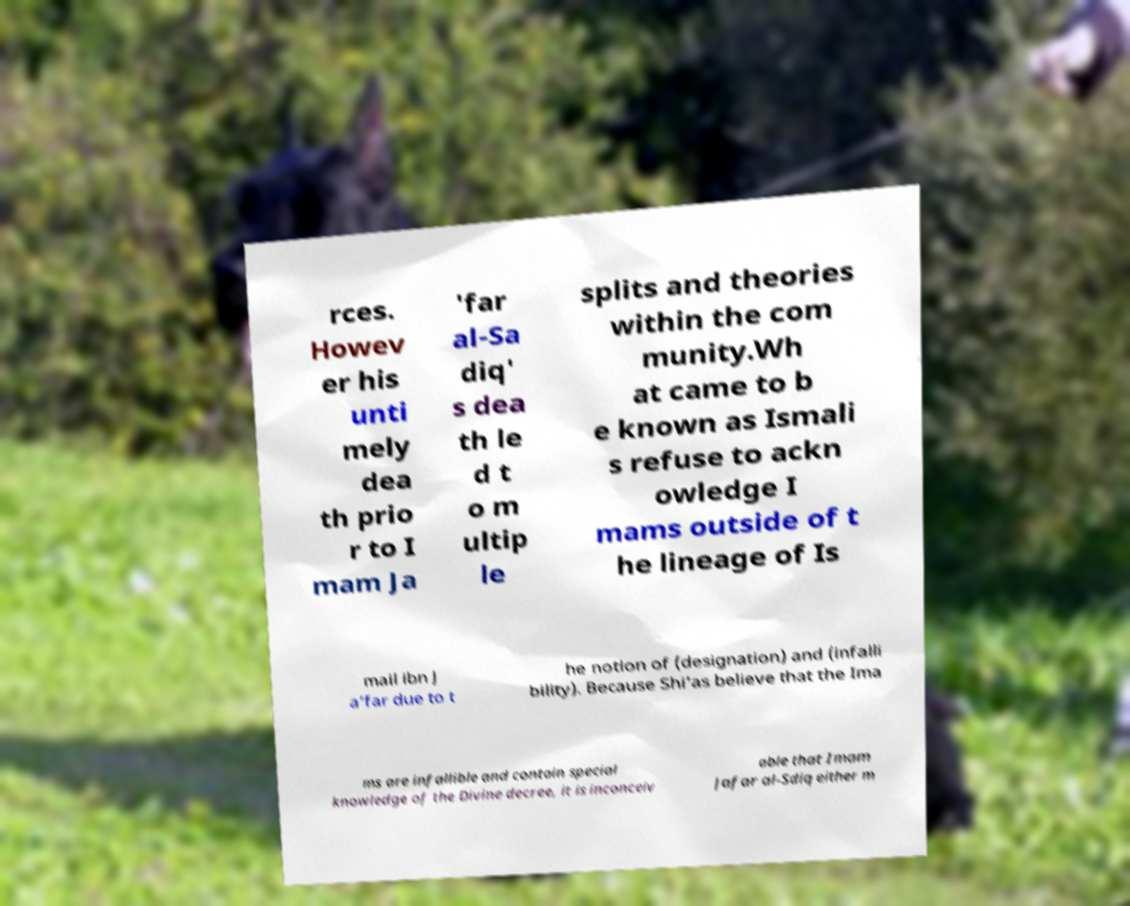There's text embedded in this image that I need extracted. Can you transcribe it verbatim? rces. Howev er his unti mely dea th prio r to I mam Ja 'far al-Sa diq' s dea th le d t o m ultip le splits and theories within the com munity.Wh at came to b e known as Ismali s refuse to ackn owledge I mams outside of t he lineage of Is mail ibn J a’far due to t he notion of (designation) and (infalli bility). Because Shi’as believe that the Ima ms are infallible and contain special knowledge of the Divine decree, it is inconceiv able that Imam Jafar al-Sdiq either m 